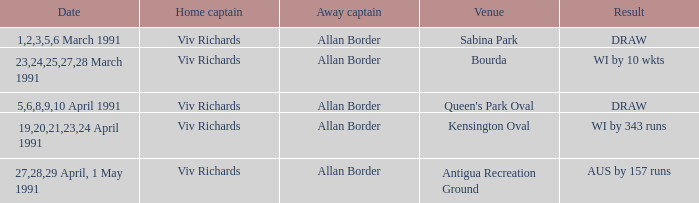What dates contained matches at the venue Bourda? 23,24,25,27,28 March 1991. 